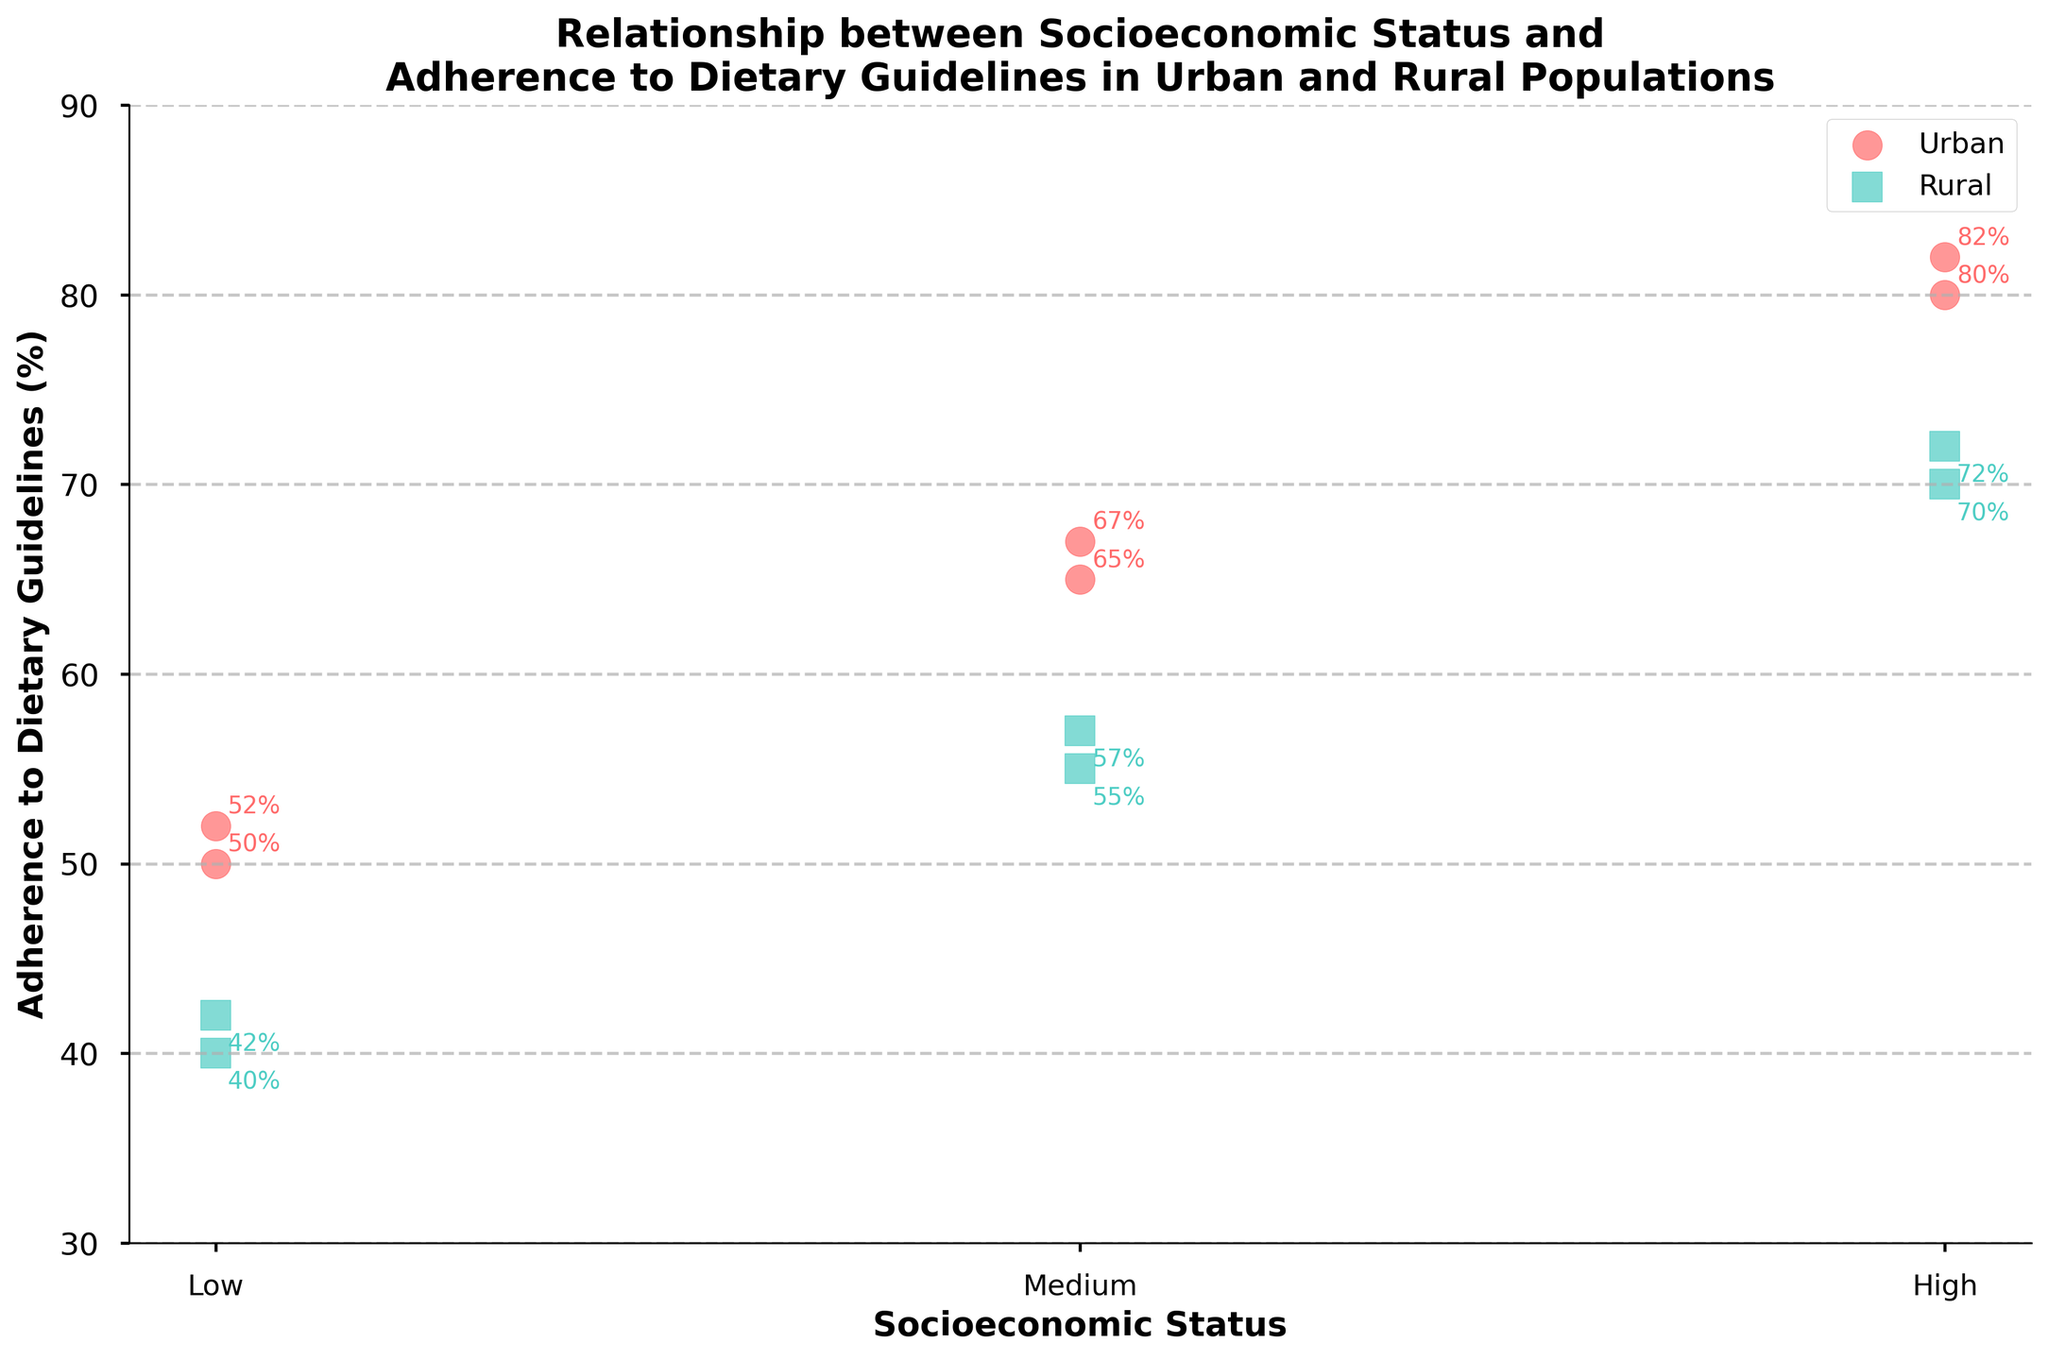What's the title of the figure? The title is written at the top of the figure, which describes the relationship being analyzed.
Answer: Relationship between Socioeconomic Status and Adherence to Dietary Guidelines in Urban and Rural Populations What is the adherence to dietary guidelines for the "Medium" socioeconomic status in the urban population? The urban "Medium" socioeconomic status points are marked with circles. Locate the "Medium" point on the x-axis and refer to the y-value.
Answer: 65% and 67% Which location, urban or rural, has higher adherence to dietary guidelines for the "Low" socioeconomic status? Compare the y-values of the points for "Low" socioeconomic status for both urban and rural populations.
Answer: Urban What's the average adherence to dietary guidelines for the "High" socioeconomic status both in urban and rural areas? Add the adherence percentages for "High" socioeconomic status in both locations and divide by the number of values. For urban: (80+82)/2 = 81%. For rural: (70+72)/2 = 71%.
Answer: Urban: 81%, Rural: 71% Which location, urban or rural, has the lowest adherence to dietary guidelines? Identify the point with the lowest y-value (adherence to dietary guidelines) and note its location.
Answer: Rural (42%) What are the labels used for the socioeconomic status on the x-axis? The labels for the x-axis are written below the x-axis ticks.
Answer: Low, Medium, High Does the adherence to dietary guidelines show an increasing trend with higher socioeconomic status in both urban and rural areas? Look at how the adherence percentages change from Low to High socioeconomic status for both urban and rural locations.
Answer: Yes What is the range of adherence to dietary guidelines values depicted on the y-axis? The range is determined by the minimum and maximum values on the y-axis.
Answer: 30% to 90% Is there any overlap in adherence to dietary guidelines between the urban "Medium" and rural "High" socioeconomic statuses? Compare the adherence percentages of urban "Medium" with rural "High".
Answer: Yes, urban "Medium" overlaps with rural "High". Both are around 65-72% 